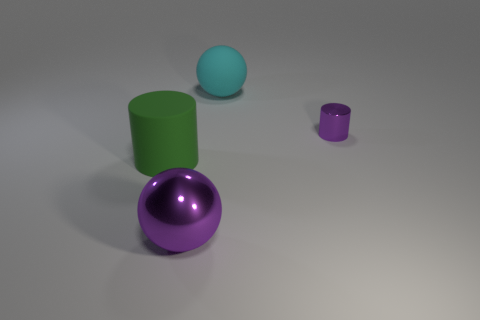Is there a large metal thing of the same color as the small cylinder?
Keep it short and to the point. Yes. What number of other things are the same shape as the cyan matte thing?
Keep it short and to the point. 1. Is the big purple thing the same shape as the cyan thing?
Offer a very short reply. Yes. There is a matte cylinder; are there any small purple objects in front of it?
Your answer should be compact. No. What number of objects are tiny purple objects or metal spheres?
Your answer should be very brief. 2. How many other things are the same size as the purple ball?
Provide a short and direct response. 2. What number of purple metal objects are both behind the matte cylinder and to the left of the small shiny object?
Provide a succinct answer. 0. Do the cylinder behind the green object and the sphere on the right side of the purple ball have the same size?
Your answer should be very brief. No. How big is the shiny thing right of the cyan sphere?
Your answer should be compact. Small. How many things are large objects to the right of the big purple object or large green objects that are on the left side of the cyan sphere?
Give a very brief answer. 2. 